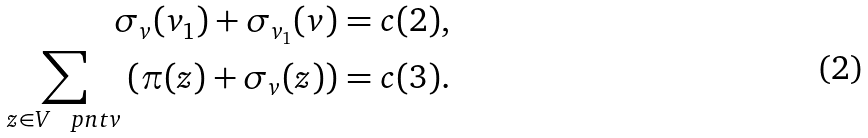<formula> <loc_0><loc_0><loc_500><loc_500>\sigma _ { v } ( v _ { 1 } ) + \sigma _ { v _ { 1 } } ( v ) = c ( 2 ) , \\ \sum _ { z \in V \ \ p n t { v } } \left ( \pi ( z ) + \sigma _ { v } ( z ) \right ) = c ( 3 ) .</formula> 